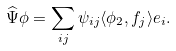Convert formula to latex. <formula><loc_0><loc_0><loc_500><loc_500>\widehat { \Psi } \phi = \sum _ { i j } \psi _ { i j } \langle \phi _ { 2 } , f _ { j } \rangle e _ { i } .</formula> 